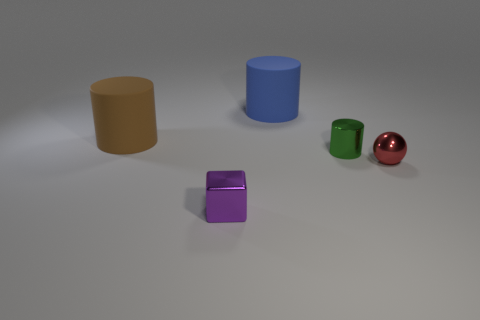Add 2 brown metal things. How many objects exist? 7 Subtract all balls. How many objects are left? 4 Add 2 purple metallic cubes. How many purple metallic cubes exist? 3 Subtract 0 gray balls. How many objects are left? 5 Subtract all large blue cylinders. Subtract all tiny blue things. How many objects are left? 4 Add 4 tiny objects. How many tiny objects are left? 7 